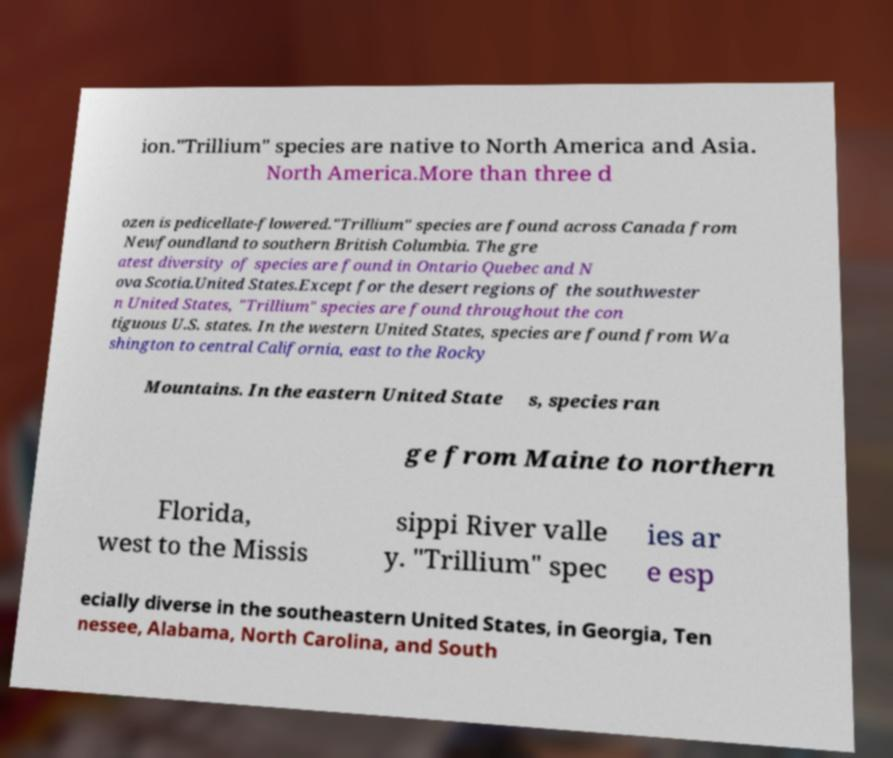What messages or text are displayed in this image? I need them in a readable, typed format. ion."Trillium" species are native to North America and Asia. North America.More than three d ozen is pedicellate-flowered."Trillium" species are found across Canada from Newfoundland to southern British Columbia. The gre atest diversity of species are found in Ontario Quebec and N ova Scotia.United States.Except for the desert regions of the southwester n United States, "Trillium" species are found throughout the con tiguous U.S. states. In the western United States, species are found from Wa shington to central California, east to the Rocky Mountains. In the eastern United State s, species ran ge from Maine to northern Florida, west to the Missis sippi River valle y. "Trillium" spec ies ar e esp ecially diverse in the southeastern United States, in Georgia, Ten nessee, Alabama, North Carolina, and South 